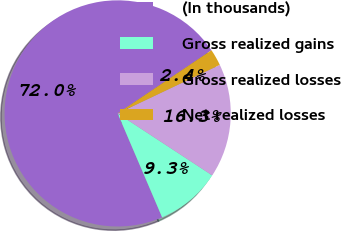<chart> <loc_0><loc_0><loc_500><loc_500><pie_chart><fcel>(In thousands)<fcel>Gross realized gains<fcel>Gross realized losses<fcel>Net realized losses<nl><fcel>72.01%<fcel>9.33%<fcel>16.3%<fcel>2.37%<nl></chart> 